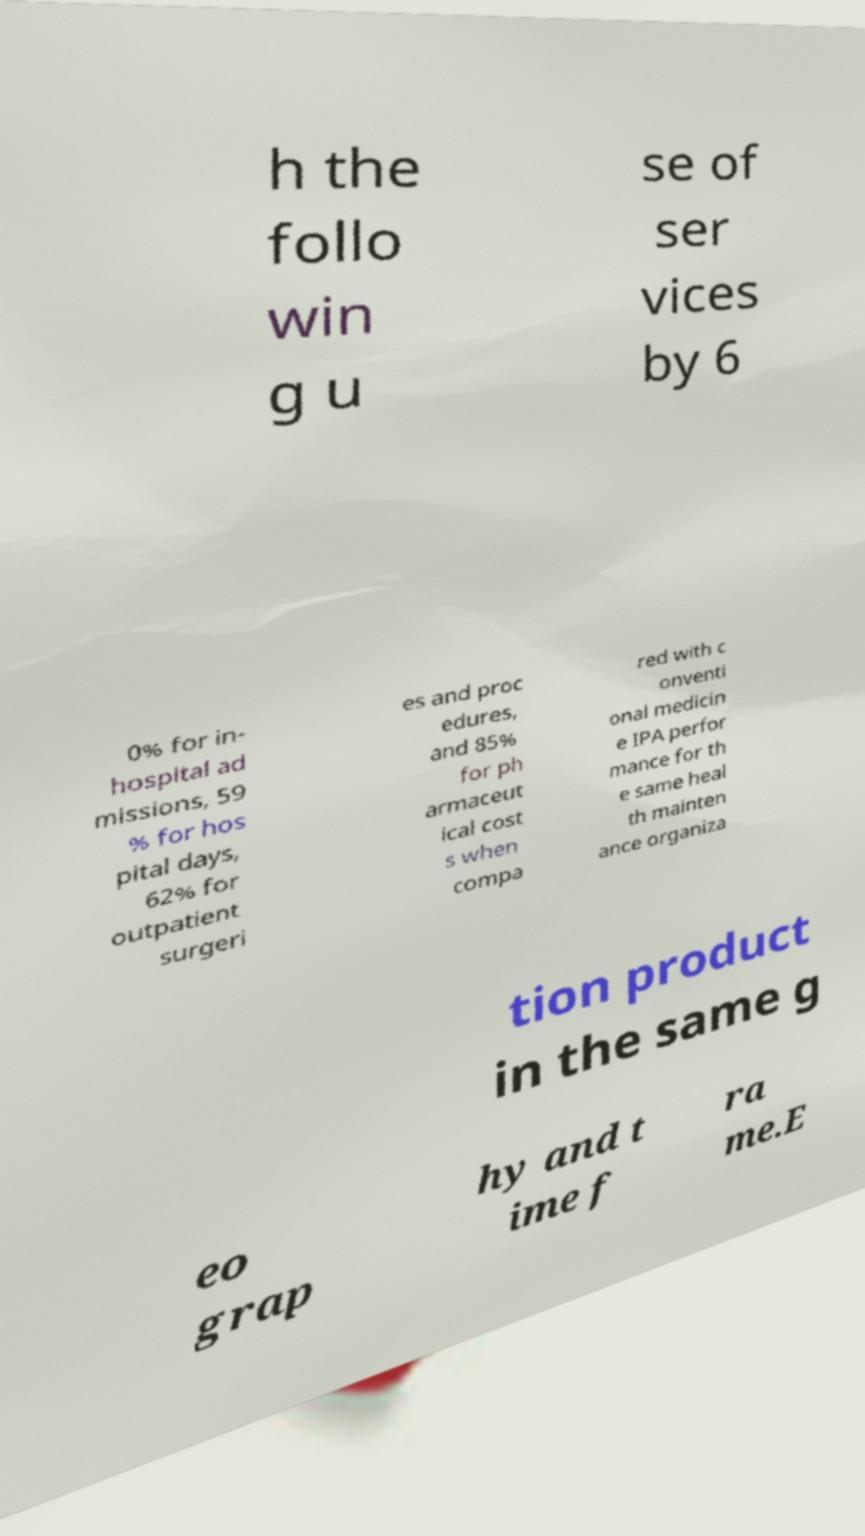Can you accurately transcribe the text from the provided image for me? h the follo win g u se of ser vices by 6 0% for in- hospital ad missions, 59 % for hos pital days, 62% for outpatient surgeri es and proc edures, and 85% for ph armaceut ical cost s when compa red with c onventi onal medicin e IPA perfor mance for th e same heal th mainten ance organiza tion product in the same g eo grap hy and t ime f ra me.E 